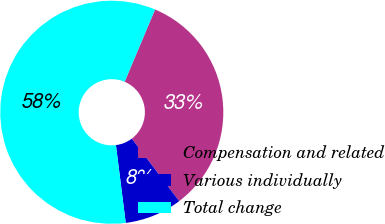Convert chart. <chart><loc_0><loc_0><loc_500><loc_500><pie_chart><fcel>Compensation and related<fcel>Various individually<fcel>Total change<nl><fcel>33.33%<fcel>8.33%<fcel>58.33%<nl></chart> 